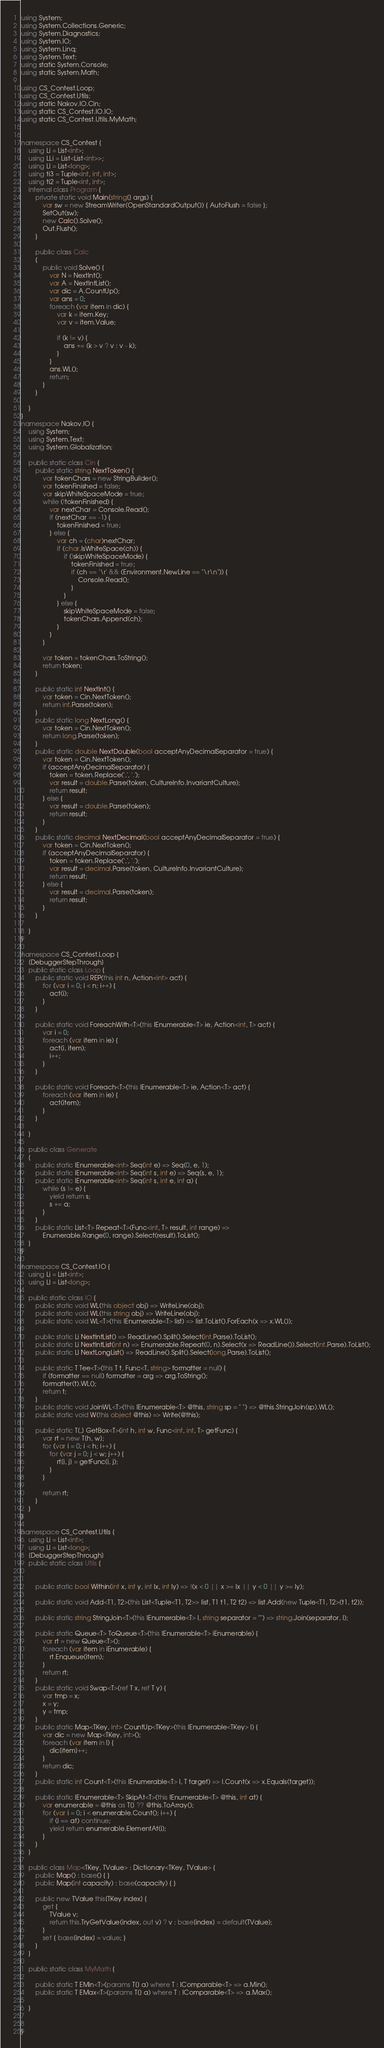Convert code to text. <code><loc_0><loc_0><loc_500><loc_500><_C#_>using System;
using System.Collections.Generic;
using System.Diagnostics;
using System.IO;
using System.Linq;
using System.Text;
using static System.Console;
using static System.Math;

using CS_Contest.Loop;
using CS_Contest.Utils;
using static Nakov.IO.Cin;
using static CS_Contest.IO.IO;
using static CS_Contest.Utils.MyMath;


namespace CS_Contest {
	using Li = List<int>;
	using LLi = List<List<int>>;
	using Ll = List<long>;
	using ti3 = Tuple<int, int, int>;
	using ti2 = Tuple<int, int>;
	internal class Program {
		private static void Main(string[] args) {
			var sw = new StreamWriter(OpenStandardOutput()) { AutoFlush = false };
			SetOut(sw);
			new Calc().Solve();
			Out.Flush();
		}

		public class Calc
		{
			public void Solve() {
			    var N = NextInt();
			    var A = NextIntList();
			    var dic = A.CountUp();
			    var ans = 0;
			    foreach (var item in dic) {
			        var k = item.Key;
			        var v = item.Value;

			        if (k != v) {
			            ans += (k > v ? v : v - k);
			        }
			    }
                ans.WL();
                return;
			}
		}

	}
}
namespace Nakov.IO {
	using System;
	using System.Text;
	using System.Globalization;

	public static class Cin {
		public static string NextToken() {
			var tokenChars = new StringBuilder();
			var tokenFinished = false;
			var skipWhiteSpaceMode = true;
			while (!tokenFinished) {
				var nextChar = Console.Read();
				if (nextChar == -1) {
					tokenFinished = true;
				} else {
					var ch = (char)nextChar;
					if (char.IsWhiteSpace(ch)) {
						if (!skipWhiteSpaceMode) {
							tokenFinished = true;
							if (ch == '\r' && (Environment.NewLine == "\r\n")) {
								Console.Read();
							}
						}
					} else {
						skipWhiteSpaceMode = false;
						tokenChars.Append(ch);
					}
				}
			}

			var token = tokenChars.ToString();
			return token;
		}

		public static int NextInt() {
			var token = Cin.NextToken();
			return int.Parse(token);
		}
		public static long NextLong() {
			var token = Cin.NextToken();
			return long.Parse(token);
		}
		public static double NextDouble(bool acceptAnyDecimalSeparator = true) {
			var token = Cin.NextToken();
			if (acceptAnyDecimalSeparator) {
				token = token.Replace(',', '.');
				var result = double.Parse(token, CultureInfo.InvariantCulture);
				return result;
			} else {
				var result = double.Parse(token);
				return result;
			}
		}
		public static decimal NextDecimal(bool acceptAnyDecimalSeparator = true) {
			var token = Cin.NextToken();
			if (acceptAnyDecimalSeparator) {
				token = token.Replace(',', '.');
				var result = decimal.Parse(token, CultureInfo.InvariantCulture);
				return result;
			} else {
				var result = decimal.Parse(token);
				return result;
			}
		}

	}
}

namespace CS_Contest.Loop {
	[DebuggerStepThrough]
	public static class Loop {
		public static void REP(this int n, Action<int> act) {
			for (var i = 0; i < n; i++) {
				act(i);
			}
		}

		public static void ForeachWith<T>(this IEnumerable<T> ie, Action<int, T> act) {
			var i = 0;
			foreach (var item in ie) {
				act(i, item);
				i++;
			}
		}

		public static void Foreach<T>(this IEnumerable<T> ie, Action<T> act) {
			foreach (var item in ie) {
				act(item);
			}
		}
		
	}

	public class Generate
	{
	    public static IEnumerable<int> Seq(int e) => Seq(0, e, 1);
		public static IEnumerable<int> Seq(int s, int e) => Seq(s, e, 1);
		public static IEnumerable<int> Seq(int s, int e, int a) {
			while (s != e) {
				yield return s;
				s += a;
			}
		}
		public static List<T> Repeat<T>(Func<int, T> result, int range) =>
			Enumerable.Range(0, range).Select(result).ToList();
	}
}

namespace CS_Contest.IO {
	using Li = List<int>;
	using Ll = List<long>;

	public static class IO {
		public static void WL(this object obj) => WriteLine(obj);
		public static void WL(this string obj) => WriteLine(obj);
		public static void WL<T>(this IEnumerable<T> list) => list.ToList().ForEach(x => x.WL());

		public static Li NextIntList() => ReadLine().Split().Select(int.Parse).ToList();
		public static Li NextIntList(int n) => Enumerable.Repeat(0, n).Select(x => ReadLine()).Select(int.Parse).ToList();
		public static Ll NextLongList() => ReadLine().Split().Select(long.Parse).ToList();

		public static T Tee<T>(this T t, Func<T, string> formatter = null) {
			if (formatter == null) formatter = arg => arg.ToString();
			formatter(t).WL();
			return t;
		}
		public static void JoinWL<T>(this IEnumerable<T> @this, string sp = " ") => @this.StringJoin(sp).WL();
		public static void W(this object @this) => Write(@this);

	    public static T[,] GetBox<T>(int h, int w, Func<int, int, T> getFunc) {
	        var rt = new T[h, w];
	        for (var i = 0; i < h; i++) {
	            for (var j = 0; j < w; j++) {
	                rt[i, j] = getFunc(i, j);
	            }
	        }

	        return rt;
	    }
	}
}

namespace CS_Contest.Utils {
	using Li = List<int>;
	using Ll = List<long>;
	[DebuggerStepThrough]
	public static class Utils {
		

		public static bool Within(int x, int y, int lx, int ly) => !(x < 0 || x >= lx || y < 0 || y >= ly);

		public static void Add<T1, T2>(this List<Tuple<T1, T2>> list, T1 t1, T2 t2) => list.Add(new Tuple<T1, T2>(t1, t2));

		public static string StringJoin<T>(this IEnumerable<T> l, string separator = "") => string.Join(separator, l);

		public static Queue<T> ToQueue<T>(this IEnumerable<T> iEnumerable) {
			var rt = new Queue<T>();
			foreach (var item in iEnumerable) {
				rt.Enqueue(item);
			}
			return rt;
		}
		public static void Swap<T>(ref T x, ref T y) {
			var tmp = x;
			x = y;
			y = tmp;
		}
		public static Map<TKey, int> CountUp<TKey>(this IEnumerable<TKey> l) {
			var dic = new Map<TKey, int>();
			foreach (var item in l) {
			    dic[item]++;
			}
			return dic;
		}
		public static int Count<T>(this IEnumerable<T> l, T target) => l.Count(x => x.Equals(target));

		public static IEnumerable<T> SkipAt<T>(this IEnumerable<T> @this, int at) {
			var enumerable = @this as T[] ?? @this.ToArray();
			for (var i = 0; i < enumerable.Count(); i++) {
				if (i == at) continue;
				yield return enumerable.ElementAt(i);
			}
		}
	}

	public class Map<TKey, TValue> : Dictionary<TKey, TValue> {
		public Map() : base() { }
		public Map(int capacity) : base(capacity) { }

		public new TValue this[TKey index] {
			get {
				TValue v;
				return this.TryGetValue(index, out v) ? v : base[index] = default(TValue);
			}
			set { base[index] = value; }
		}
	}

	public static class MyMath {
		
		public static T EMin<T>(params T[] a) where T : IComparable<T> => a.Min();
		public static T EMax<T>(params T[] a) where T : IComparable<T> => a.Max();

	}


}

</code> 